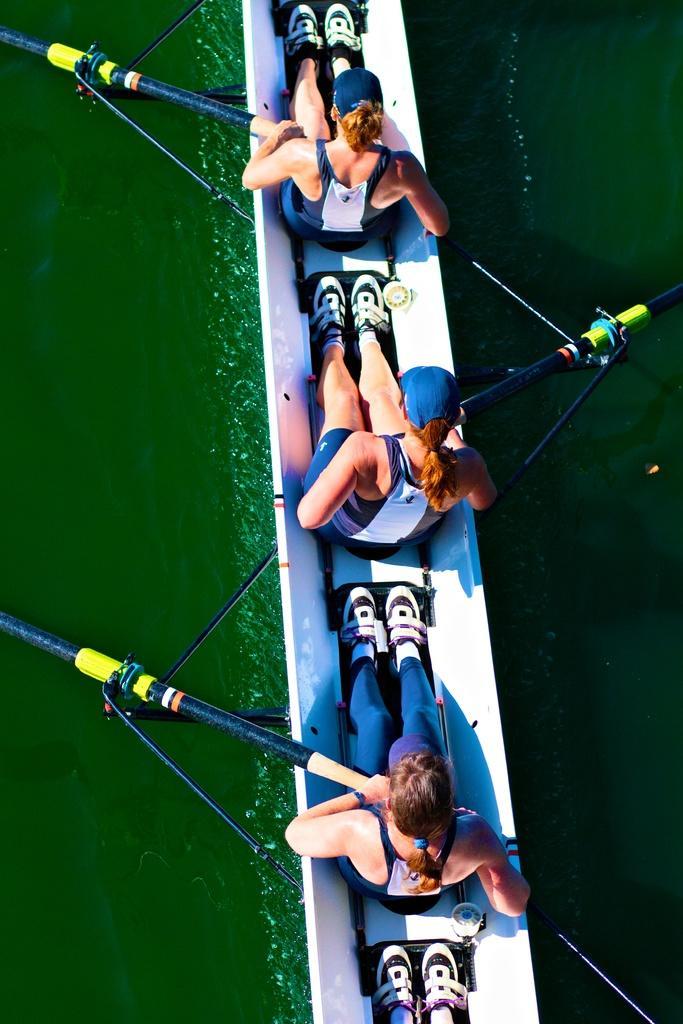Please provide a concise description of this image. In this image, I can see three persons are boating in the water and are holding some objects in their hand. This picture might be taken in a day. 